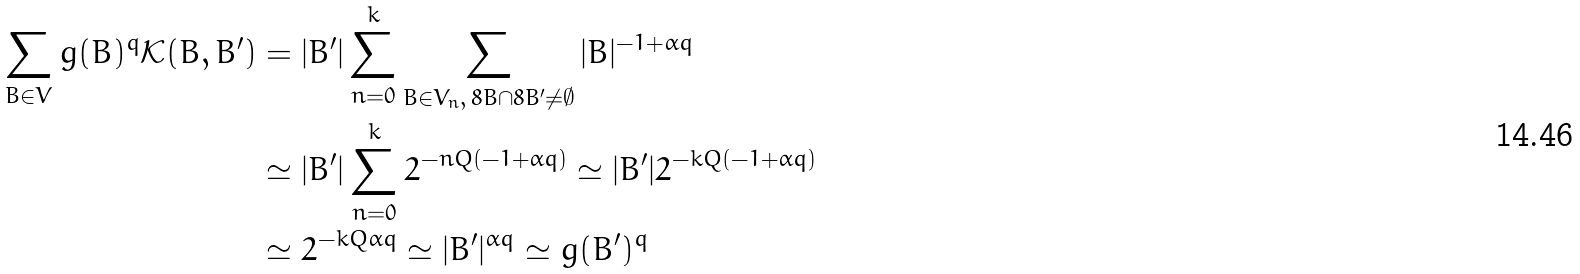<formula> <loc_0><loc_0><loc_500><loc_500>\sum _ { B \in V } g ( B ) ^ { q } \mathcal { K } ( B , B ^ { \prime } ) & = | B ^ { \prime } | \sum _ { n = 0 } ^ { k } \sum _ { B \in V _ { n } , \, 8 B \cap 8 B ^ { \prime } \ne \emptyset } | B | ^ { - 1 + \alpha q } \\ & \simeq | B ^ { \prime } | \sum _ { n = 0 } ^ { k } 2 ^ { - n Q ( - 1 + \alpha q ) } \simeq | B ^ { \prime } | 2 ^ { - k Q ( - 1 + \alpha q ) } \\ & \simeq 2 ^ { - k Q \alpha q } \simeq | B ^ { \prime } | ^ { \alpha q } \simeq g ( B ^ { \prime } ) ^ { q }</formula> 